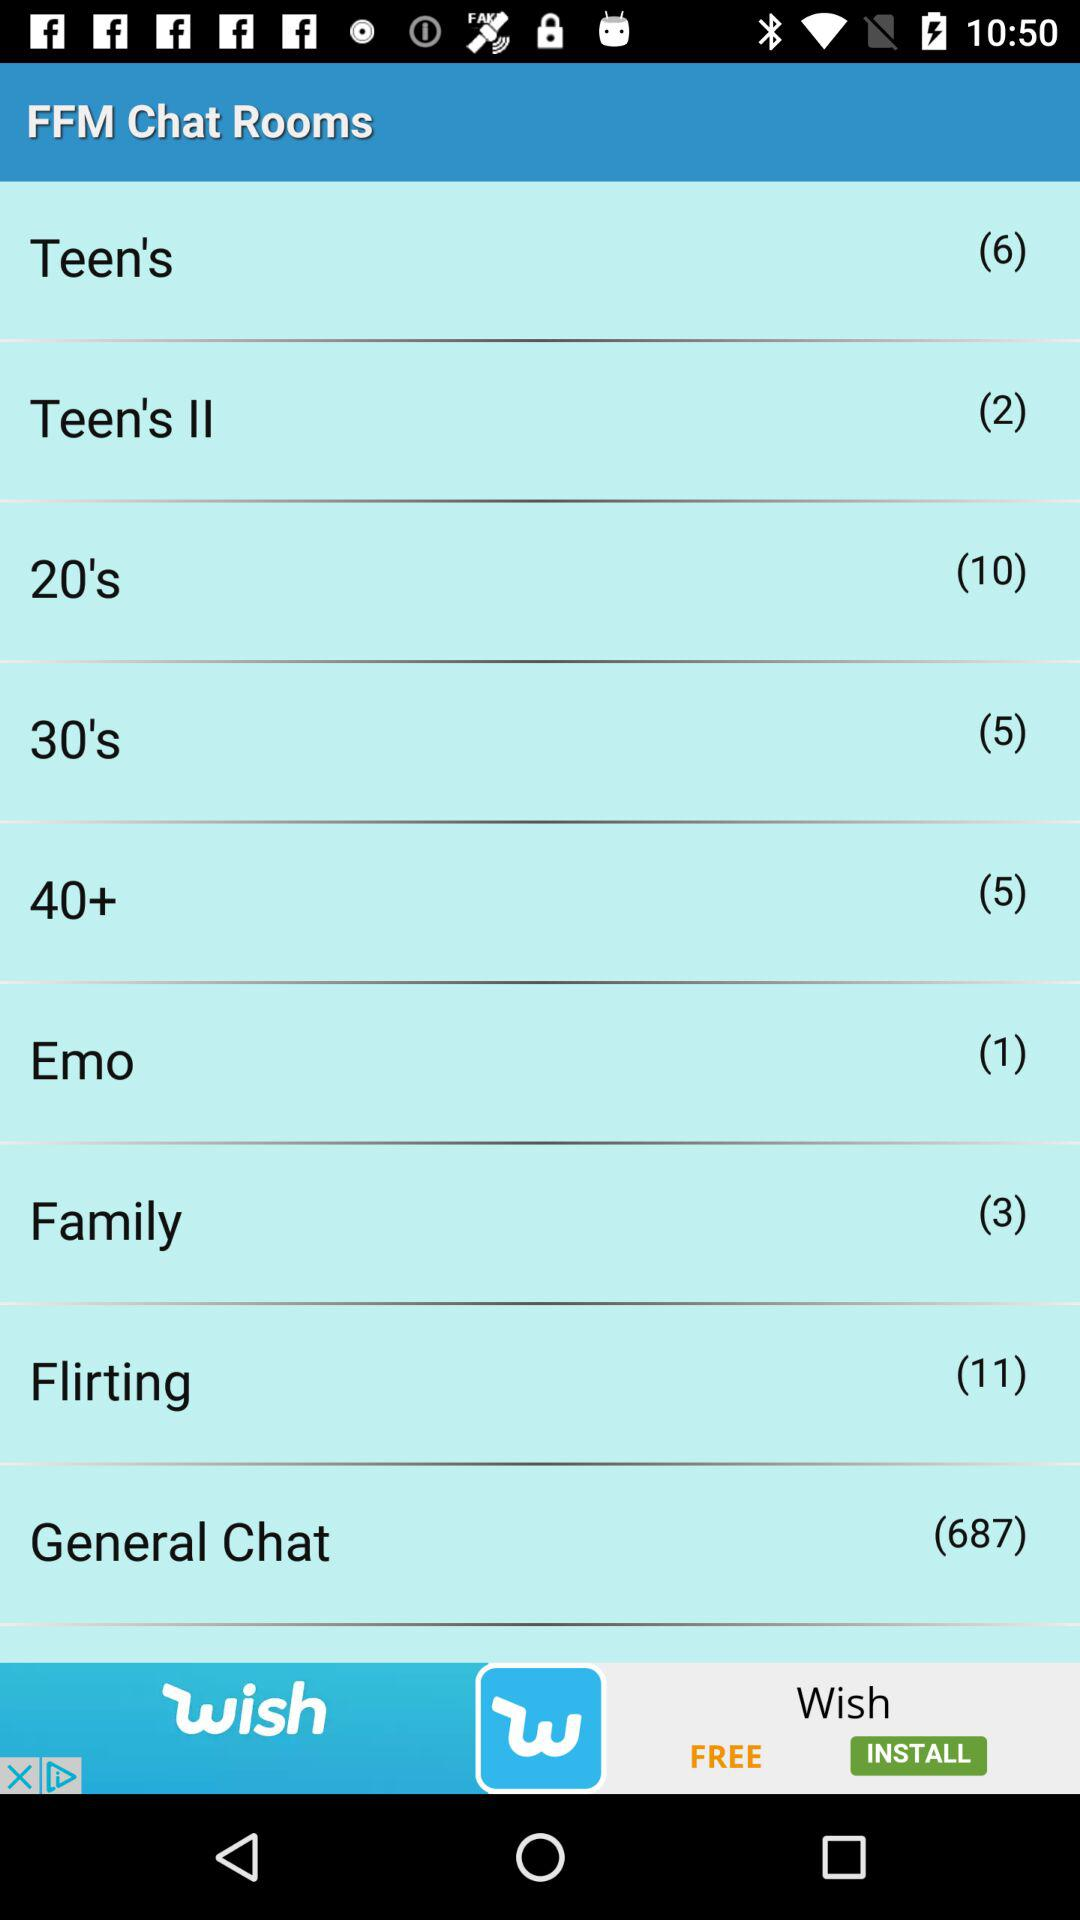What's the number for "General Chat"? The number for "General Chat" is 687. 